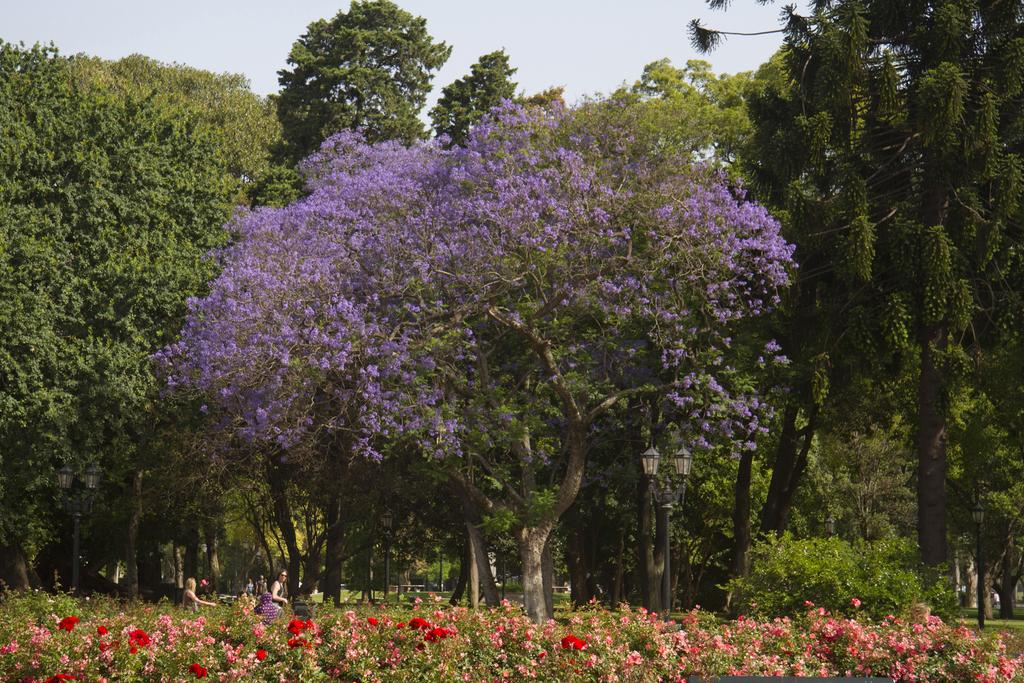What types of living organisms can be seen in the image? People, plants, flowers, and trees are visible in the image. What part of the natural environment is visible in the image? The sky is visible in the image. What type of flame can be seen in the image? There is no flame present in the image. What type of structure can be seen in the image? The image does not depict any specific structure. What type of chair can be seen in the image? There is no chair present in the image. 